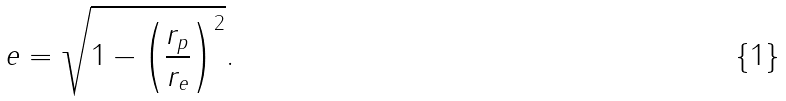<formula> <loc_0><loc_0><loc_500><loc_500>e = \sqrt { 1 - \left ( \frac { r _ { p } } { r _ { e } } \right ) ^ { 2 } } .</formula> 